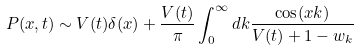<formula> <loc_0><loc_0><loc_500><loc_500>P ( x , t ) \sim V ( t ) \delta ( x ) + \frac { V ( t ) } { \pi } \int _ { 0 } ^ { \infty } d k \frac { \cos ( x k ) } { V ( t ) + 1 - w _ { k } }</formula> 